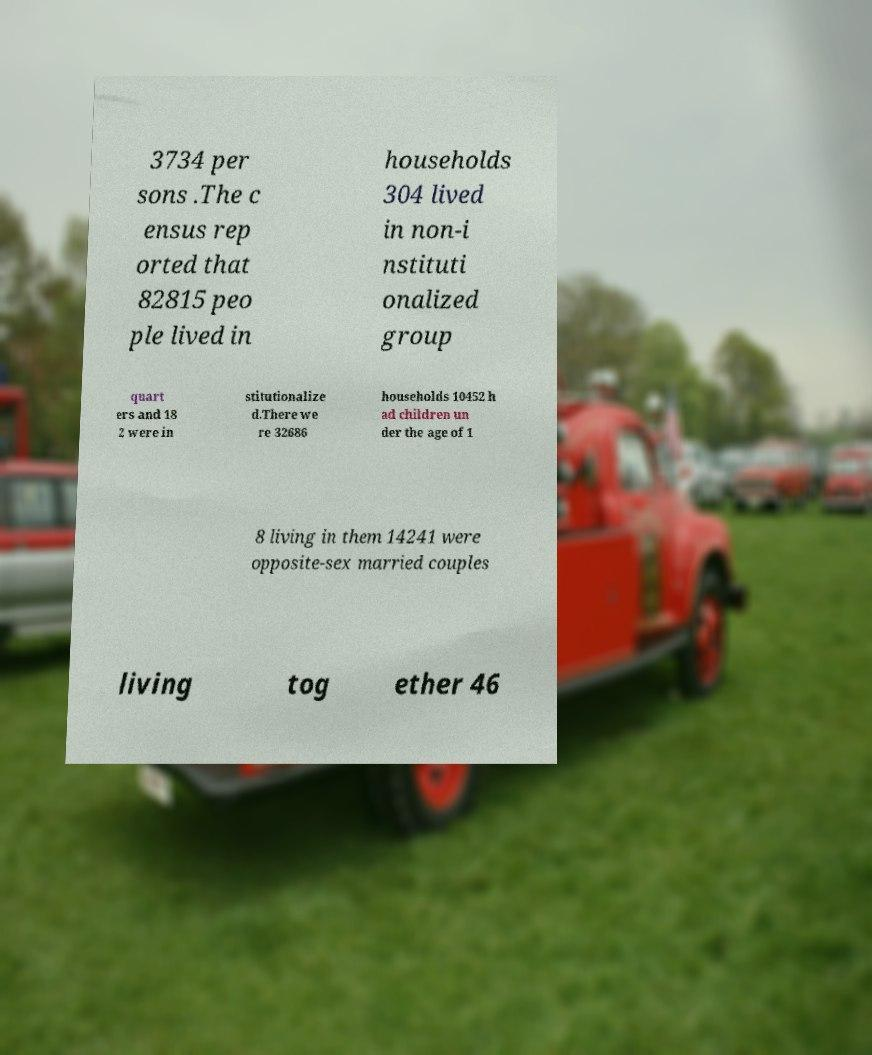Could you assist in decoding the text presented in this image and type it out clearly? 3734 per sons .The c ensus rep orted that 82815 peo ple lived in households 304 lived in non-i nstituti onalized group quart ers and 18 2 were in stitutionalize d.There we re 32686 households 10452 h ad children un der the age of 1 8 living in them 14241 were opposite-sex married couples living tog ether 46 